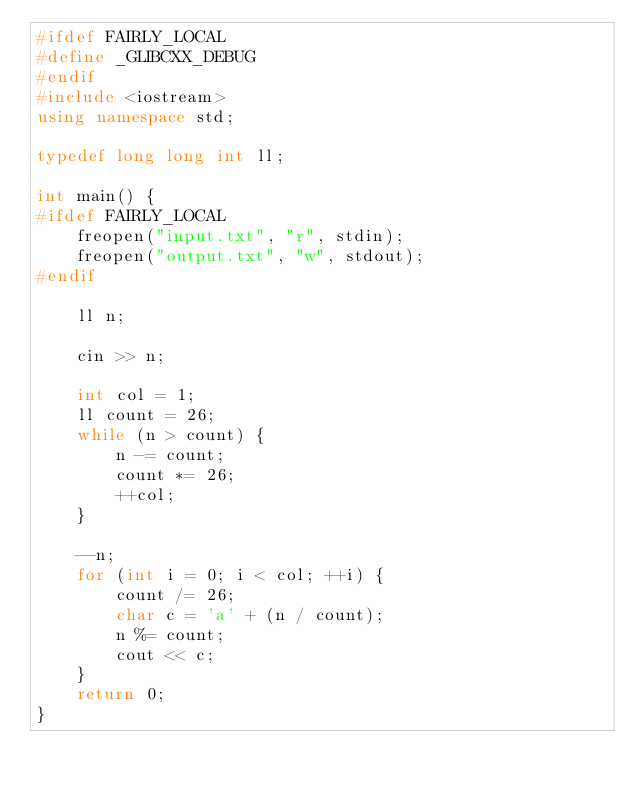<code> <loc_0><loc_0><loc_500><loc_500><_C++_>#ifdef FAIRLY_LOCAL
#define _GLIBCXX_DEBUG
#endif
#include <iostream>
using namespace std;

typedef long long int ll;

int main() {
#ifdef FAIRLY_LOCAL
    freopen("input.txt", "r", stdin);
    freopen("output.txt", "w", stdout);
#endif

    ll n;

    cin >> n;

    int col = 1;
    ll count = 26;
    while (n > count) {
        n -= count;
        count *= 26;
        ++col;
    }

    --n;
    for (int i = 0; i < col; ++i) {
        count /= 26;
        char c = 'a' + (n / count);
        n %= count;
        cout << c;
    }
    return 0;
}</code> 